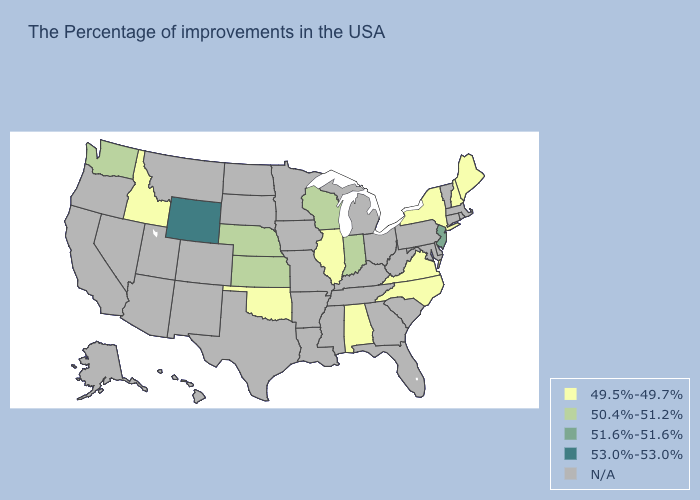Name the states that have a value in the range 53.0%-53.0%?
Quick response, please. Wyoming. What is the highest value in the USA?
Concise answer only. 53.0%-53.0%. Is the legend a continuous bar?
Be succinct. No. What is the value of North Carolina?
Write a very short answer. 49.5%-49.7%. Among the states that border New Hampshire , which have the lowest value?
Answer briefly. Maine. What is the value of South Dakota?
Concise answer only. N/A. Name the states that have a value in the range N/A?
Write a very short answer. Massachusetts, Rhode Island, Vermont, Connecticut, Delaware, Maryland, Pennsylvania, South Carolina, West Virginia, Ohio, Florida, Georgia, Michigan, Kentucky, Tennessee, Mississippi, Louisiana, Missouri, Arkansas, Minnesota, Iowa, Texas, South Dakota, North Dakota, Colorado, New Mexico, Utah, Montana, Arizona, Nevada, California, Oregon, Alaska, Hawaii. Does the map have missing data?
Keep it brief. Yes. Name the states that have a value in the range 51.6%-51.6%?
Short answer required. New Jersey. What is the value of Alabama?
Concise answer only. 49.5%-49.7%. Which states hav the highest value in the MidWest?
Give a very brief answer. Indiana, Wisconsin, Kansas, Nebraska. 